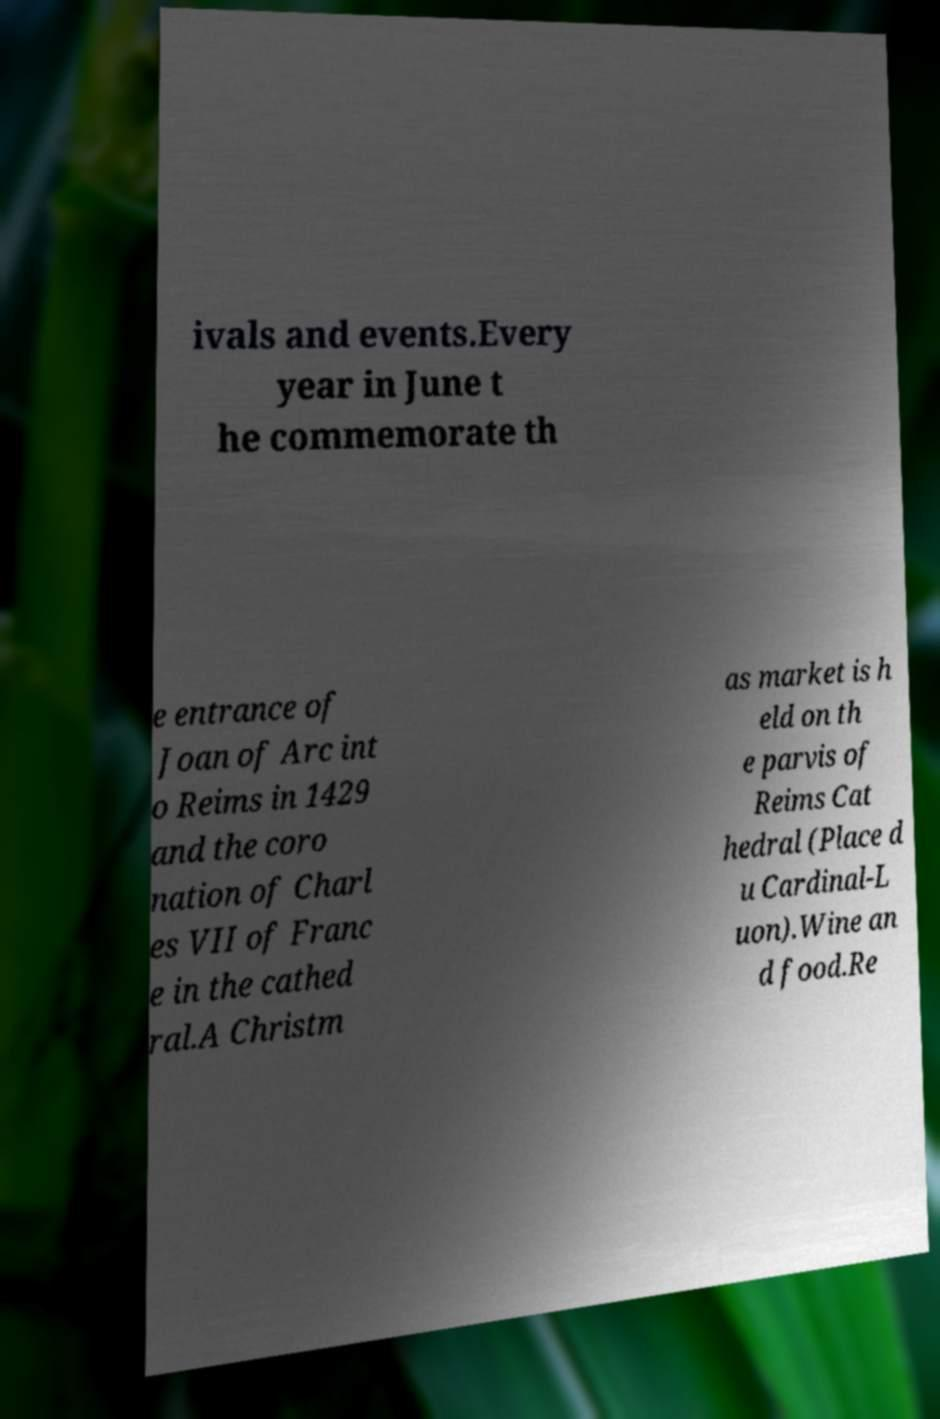What messages or text are displayed in this image? I need them in a readable, typed format. ivals and events.Every year in June t he commemorate th e entrance of Joan of Arc int o Reims in 1429 and the coro nation of Charl es VII of Franc e in the cathed ral.A Christm as market is h eld on th e parvis of Reims Cat hedral (Place d u Cardinal-L uon).Wine an d food.Re 